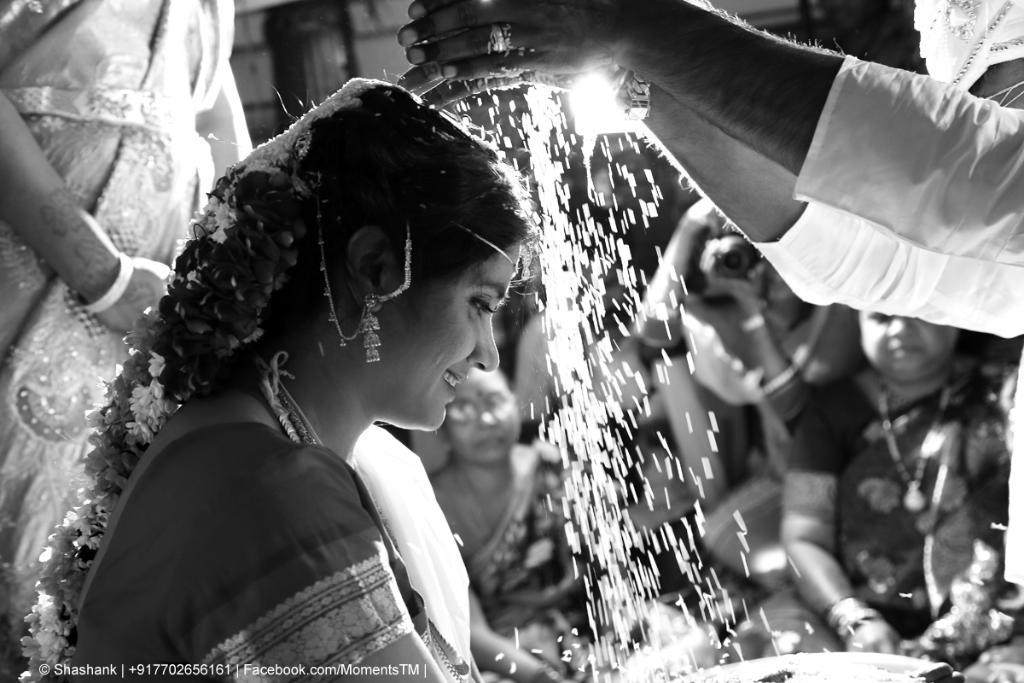What type of event is depicted in the image? The image depicts a traditional Indian wedding. What action is the groom performing in the image? The groom is pouring sacred rice on the bride. Are there any other people present in the image besides the bride and groom? Yes, there are people around the bride and groom. What type of shoes is the bride wearing during the quince activity in the image? There is no quince activity or mention of shoes in the image; it depicts a traditional Indian wedding with the groom pouring sacred rice on the bride. 